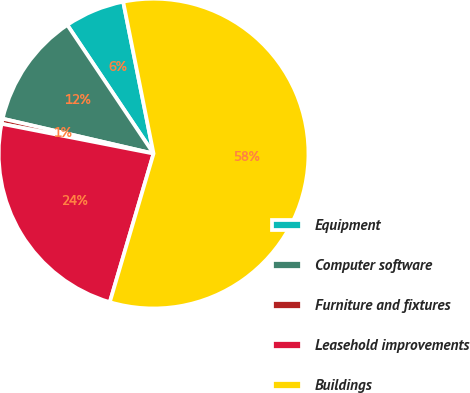Convert chart to OTSL. <chart><loc_0><loc_0><loc_500><loc_500><pie_chart><fcel>Equipment<fcel>Computer software<fcel>Furniture and fixtures<fcel>Leasehold improvements<fcel>Buildings<nl><fcel>6.26%<fcel>11.98%<fcel>0.54%<fcel>23.52%<fcel>57.7%<nl></chart> 